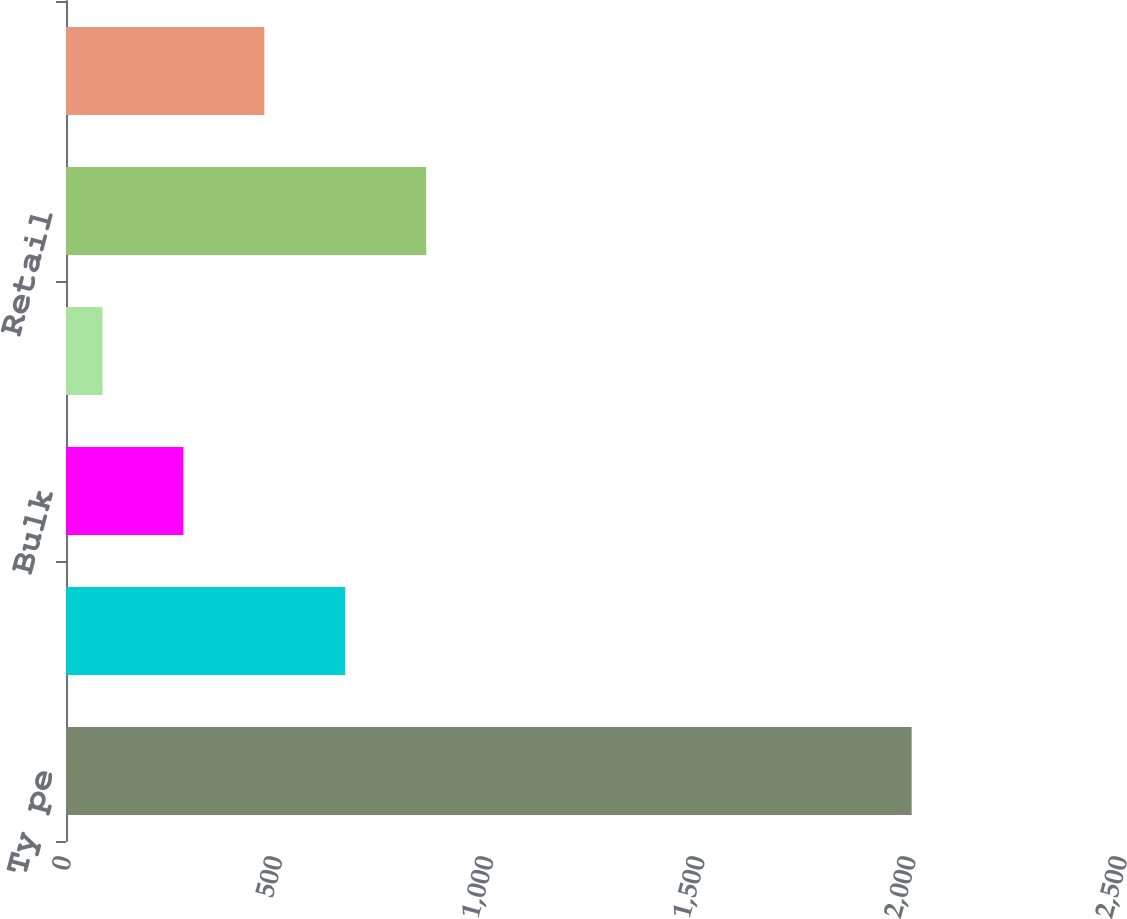<chart> <loc_0><loc_0><loc_500><loc_500><bar_chart><fcel>Ty pe<fcel>Service Centers<fcel>Bulk<fcel>Office<fcel>Retail<fcel>To tal<nl><fcel>2002<fcel>661.15<fcel>278.05<fcel>86.5<fcel>852.7<fcel>469.6<nl></chart> 